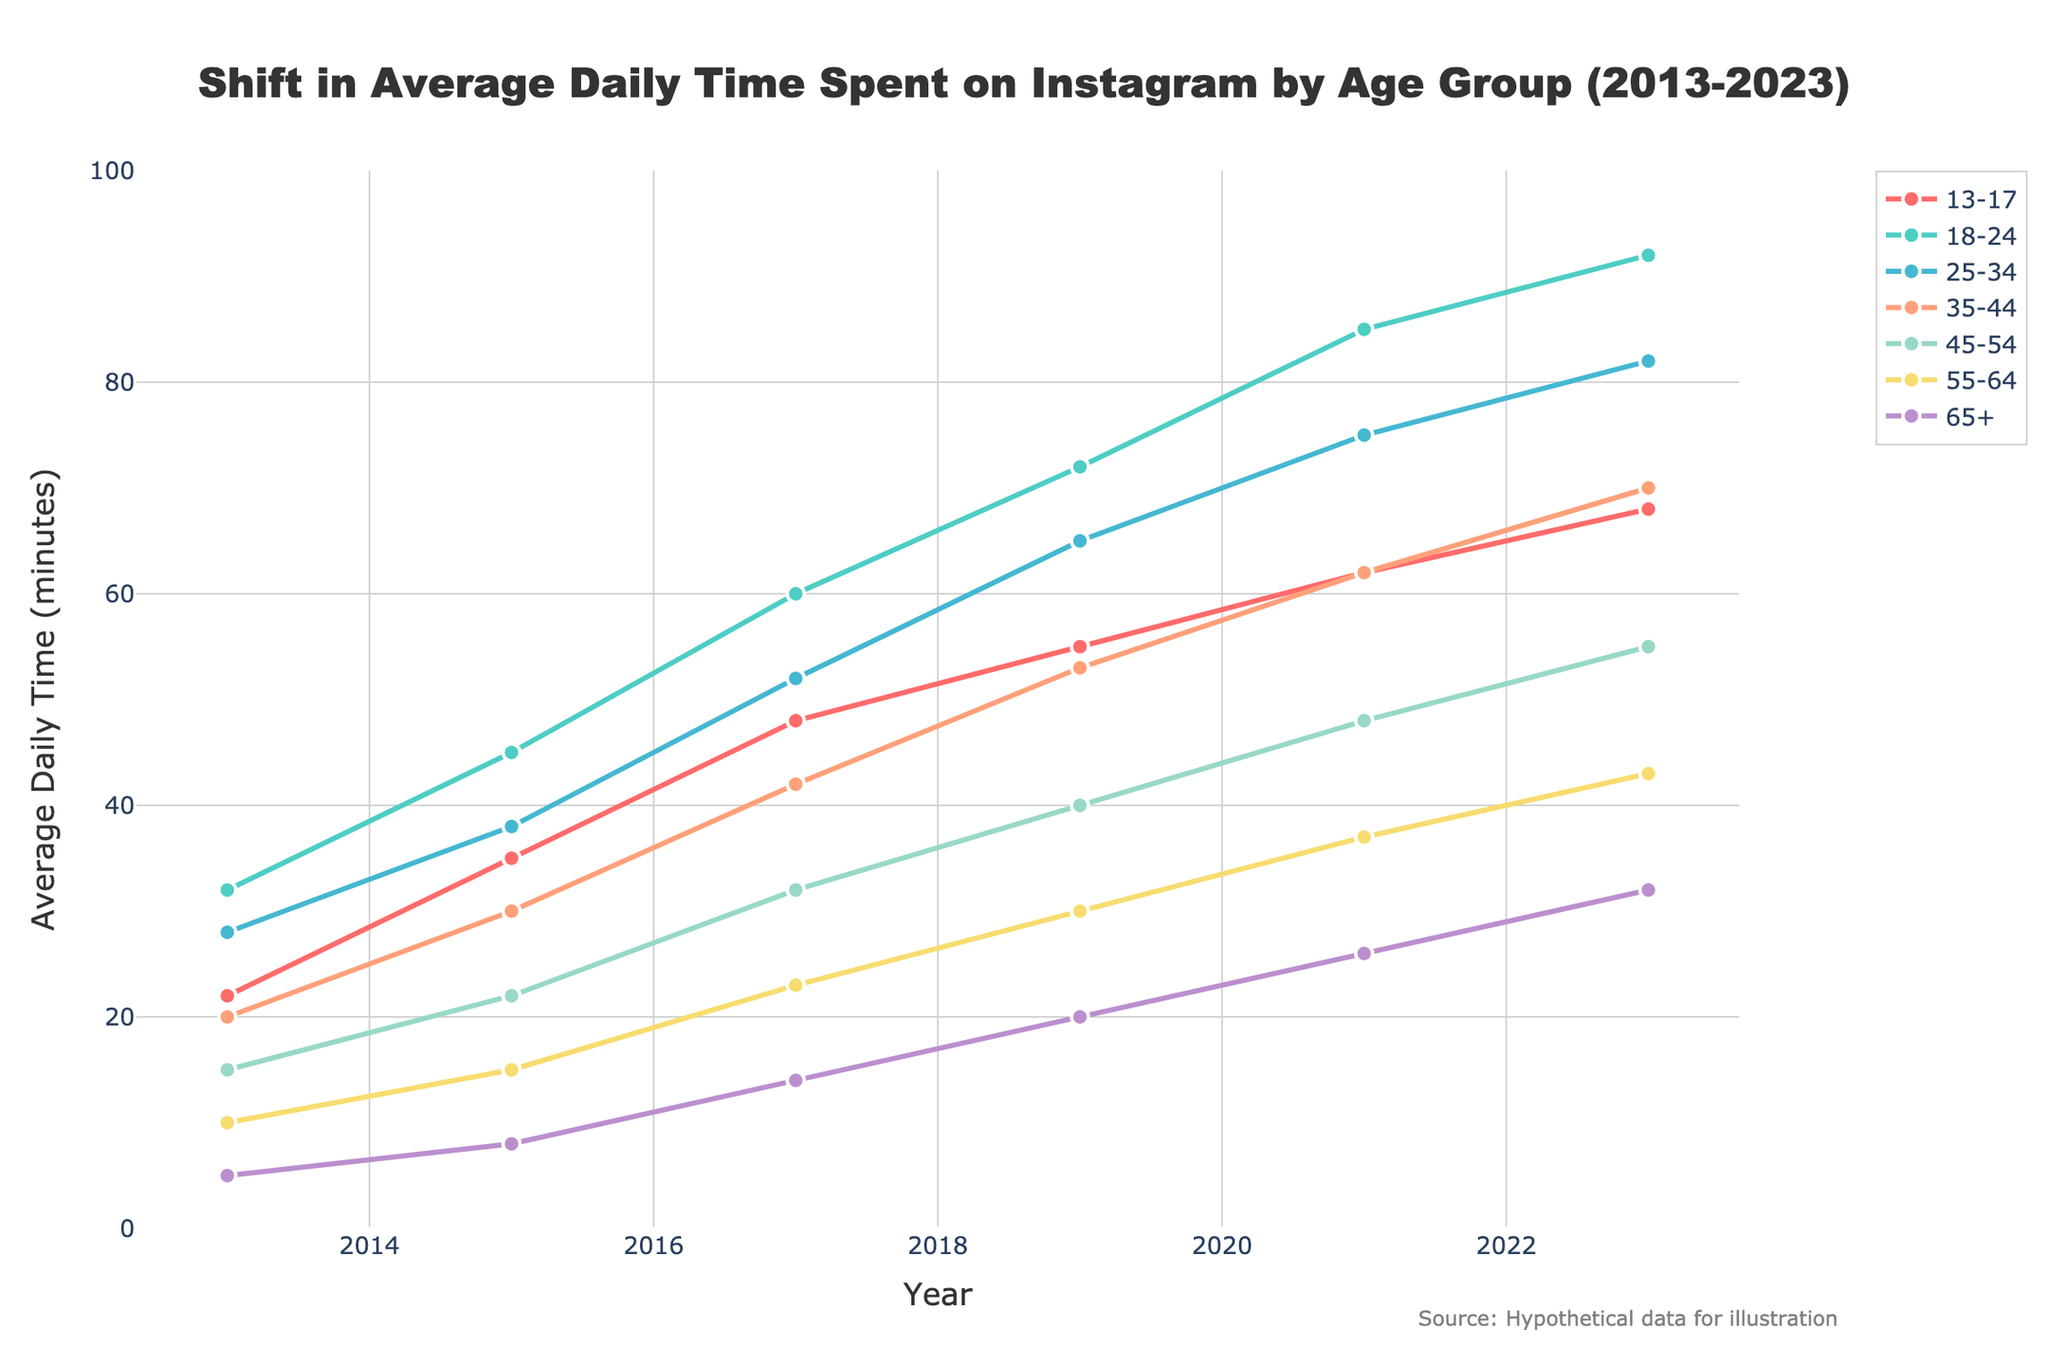What is the average daily time spent on Instagram by the 18-24 age group in 2023? Look at the data point for the 18-24 age group in the year 2023, which is 92 minutes.
Answer: 92 minutes Which age group showed the highest average daily time spent on Instagram in 2019? Compare the values for all age groups in the year 2019. The 18-24 age group has the highest value, which is 72 minutes.
Answer: 18-24 age group How much has the average daily time spent on Instagram increased for the 35-44 age group from 2013 to 2023? Subtract the 2013 value for the 35-44 age group from the 2023 value: 70 - 20 = 50 minutes.
Answer: 50 minutes By how much did the average daily time for the 13-17 age group change between 2017 and 2023? Find the values for 2017 and 2023 for the 13-17 age group: 68 - 48.
Answer: 20 minutes What's the difference in average daily time spent on Instagram between the 25-34 and 45-54 age groups in 2023? Subtract the 2023 value for the 45-54 age group from the 25-34 age group: 82 - 55 = 27 minutes.
Answer: 27 minutes Which age group's average daily usage grew the fastest between 2013 and 2023? Calculate the increase for each age group and compare. The values in minutes are: 
13-17: 68-22=46
18-24: 92-32=60
25-34: 82-28=54
35-44: 70-20=50
45-54: 55-15=40
55-64: 43-10=33
65+: 32-5=27
The 18-24 age group grew by 60 minutes, the most significant increase.
Answer: 18-24 age group What is the color used to represent the age group 25-34 in the plot? Looking at the given code, the 25-34 age group is represented by the color corresponding to the 3rd item in the colors list, which is '#45B7D1'. This refers to a shade of blue.
Answer: Blue Which year shows the largest jump in average daily time for the 55-64 age group? Review the data points for the 55-64 age group across all years and compute the differences. The biggest jump is from 15 minutes in 2015 to 23 minutes in 2017, a difference of 8 minutes.
Answer: Between 2015 and 2017 What is the total increase in average daily time spent by all age groups combined from 2013 to 2023? Calculate the total for each year and compare: 2013: 22+32+28+20+15+10+5=132,
2023: 68+92+82+70+55+43+32=442,
Total increase = 442 - 132 = 310 minutes.
Answer: 310 minutes Which age group had the lowest average daily time spent on Instagram in 2017? Compare the values for each age group in 2017. The 65+ age group has the lowest value, which is 14 minutes.
Answer: 65+ age group 